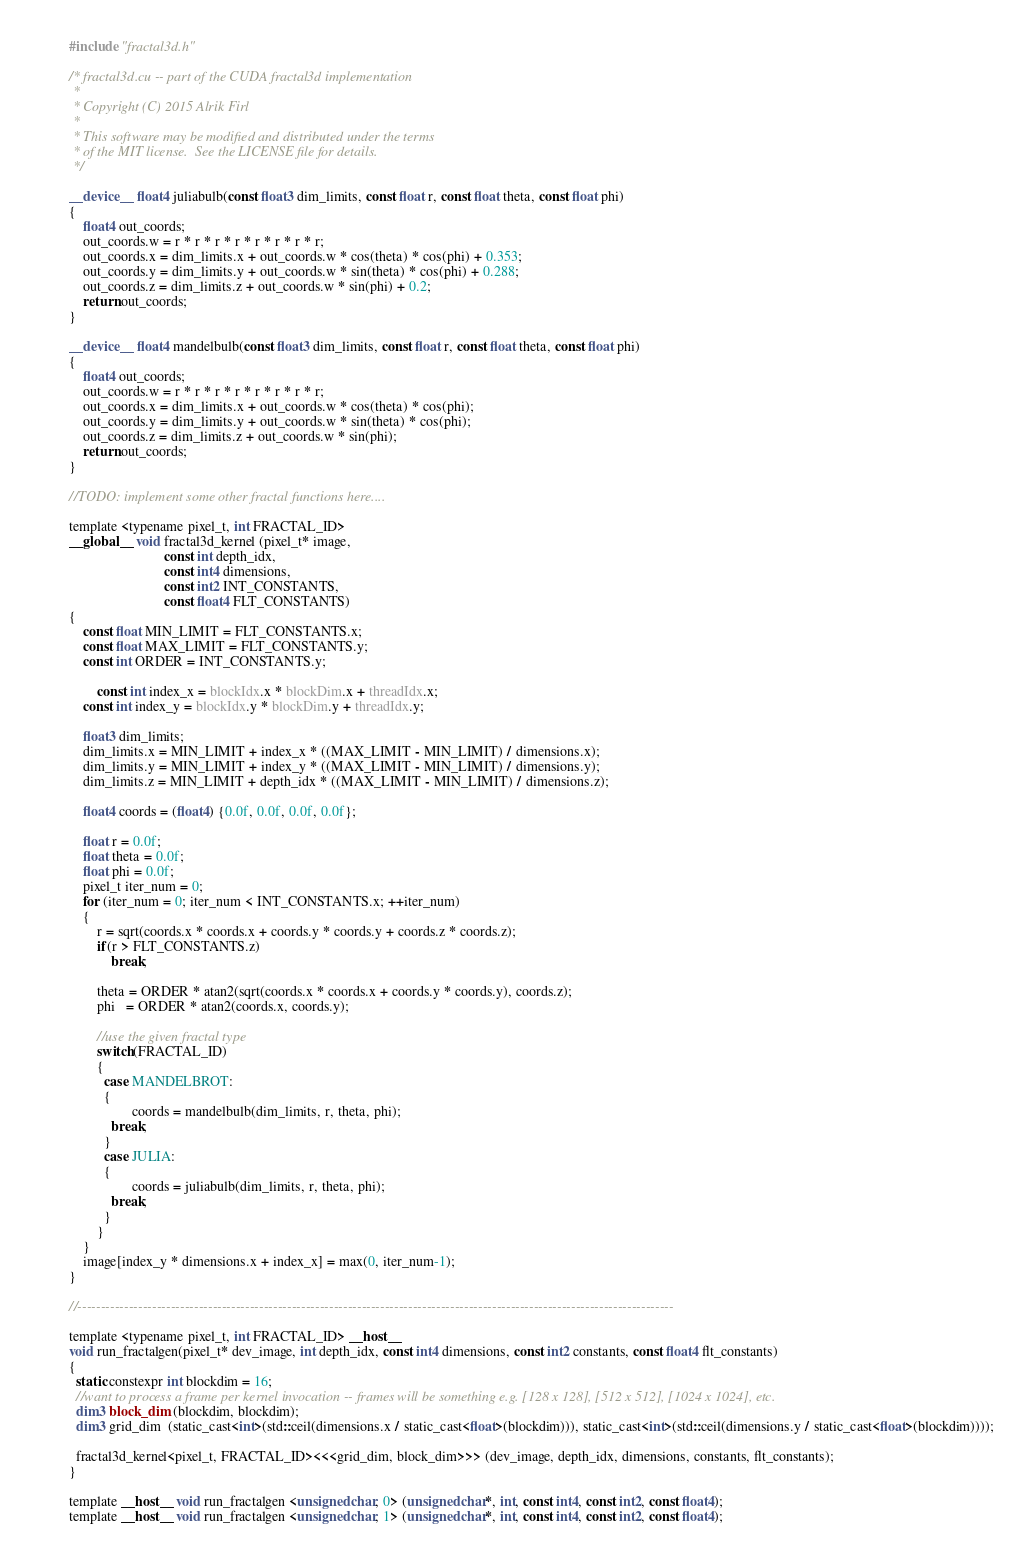Convert code to text. <code><loc_0><loc_0><loc_500><loc_500><_Cuda_>#include "fractal3d.h"

/* fractal3d.cu -- part of the CUDA fractal3d implementation 
 *
 * Copyright (C) 2015 Alrik Firl 
 *
 * This software may be modified and distributed under the terms
 * of the MIT license.  See the LICENSE file for details.
 */

__device__ float4 juliabulb(const float3 dim_limits, const float r, const float theta, const float phi)
{
    float4 out_coords;
    out_coords.w = r * r * r * r * r * r * r * r;
    out_coords.x = dim_limits.x + out_coords.w * cos(theta) * cos(phi) + 0.353;
    out_coords.y = dim_limits.y + out_coords.w * sin(theta) * cos(phi) + 0.288;
    out_coords.z = dim_limits.z + out_coords.w * sin(phi) + 0.2;
    return out_coords;
}

__device__ float4 mandelbulb(const float3 dim_limits, const float r, const float theta, const float phi)
{
    float4 out_coords;
    out_coords.w = r * r * r * r * r * r * r * r;
    out_coords.x = dim_limits.x + out_coords.w * cos(theta) * cos(phi);
    out_coords.y = dim_limits.y + out_coords.w * sin(theta) * cos(phi);
    out_coords.z = dim_limits.z + out_coords.w * sin(phi);
    return out_coords;
}

//TODO: implement some other fractal functions here....

template <typename pixel_t, int FRACTAL_ID> 
__global__ void fractal3d_kernel (pixel_t* image,
                           const int depth_idx,
                           const int4 dimensions,
                           const int2 INT_CONSTANTS,
                           const float4 FLT_CONSTANTS)
{
    const float MIN_LIMIT = FLT_CONSTANTS.x;
    const float MAX_LIMIT = FLT_CONSTANTS.y;
    const int ORDER = INT_CONSTANTS.y;

		const int index_x = blockIdx.x * blockDim.x + threadIdx.x;    
    const int index_y = blockIdx.y * blockDim.y + threadIdx.y;

    float3 dim_limits;
    dim_limits.x = MIN_LIMIT + index_x * ((MAX_LIMIT - MIN_LIMIT) / dimensions.x);
    dim_limits.y = MIN_LIMIT + index_y * ((MAX_LIMIT - MIN_LIMIT) / dimensions.y);
    dim_limits.z = MIN_LIMIT + depth_idx * ((MAX_LIMIT - MIN_LIMIT) / dimensions.z);

    float4 coords = (float4) {0.0f, 0.0f, 0.0f, 0.0f};

    float r = 0.0f;
    float theta = 0.0f;
    float phi = 0.0f;
    pixel_t iter_num = 0;
    for (iter_num = 0; iter_num < INT_CONSTANTS.x; ++iter_num)
    {
        r = sqrt(coords.x * coords.x + coords.y * coords.y + coords.z * coords.z);
        if(r > FLT_CONSTANTS.z)
            break;

        theta = ORDER * atan2(sqrt(coords.x * coords.x + coords.y * coords.y), coords.z);
        phi   = ORDER * atan2(coords.x, coords.y);
        
        //use the given fractal type
        switch(FRACTAL_ID)
        {
          case MANDELBROT:
          {
  				  coords = mandelbulb(dim_limits, r, theta, phi);  
            break;
          }
          case JULIA:
          {
  				  coords = juliabulb(dim_limits, r, theta, phi);  
            break;
          }        
        }
    }
    image[index_y * dimensions.x + index_x] = max(0, iter_num-1);
}

//--------------------------------------------------------------------------------------------------------------------------------

template <typename pixel_t, int FRACTAL_ID> __host__ 
void run_fractalgen(pixel_t* dev_image, int depth_idx, const int4 dimensions, const int2 constants, const float4 flt_constants)
{
  static constexpr int blockdim = 16;
  //want to process a frame per kernel invocation -- frames will be something e.g. [128 x 128], [512 x 512], [1024 x 1024], etc. 
  dim3 block_dim (blockdim, blockdim);
  dim3 grid_dim  (static_cast<int>(std::ceil(dimensions.x / static_cast<float>(blockdim))), static_cast<int>(std::ceil(dimensions.y / static_cast<float>(blockdim))));

  fractal3d_kernel<pixel_t, FRACTAL_ID><<<grid_dim, block_dim>>> (dev_image, depth_idx, dimensions, constants, flt_constants);
}

template __host__ void run_fractalgen <unsigned char, 0> (unsigned char*, int, const int4, const int2, const float4);
template __host__ void run_fractalgen <unsigned char, 1> (unsigned char*, int, const int4, const int2, const float4);

</code> 